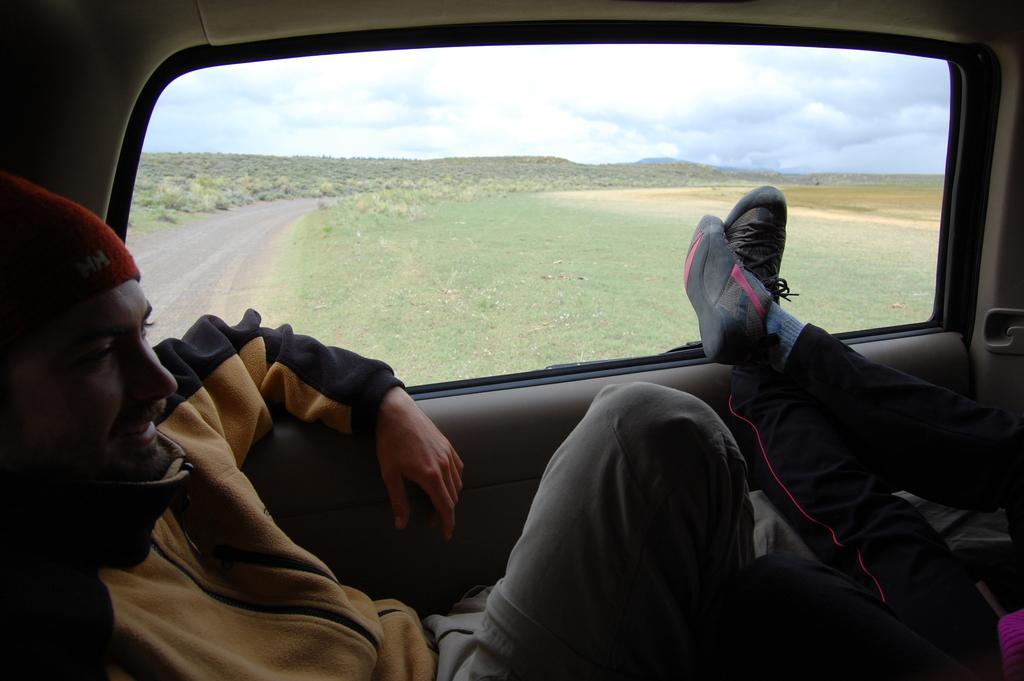Please provide a concise description of this image. In this image there are two people sitting inside a car, from the window we can see the road and grass on the surface. 